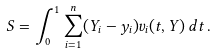Convert formula to latex. <formula><loc_0><loc_0><loc_500><loc_500>S = \int _ { 0 } ^ { 1 } \sum _ { i = 1 } ^ { n } ( Y _ { i } - y _ { i } ) v _ { i } ( t , Y ) \, d t \, .</formula> 